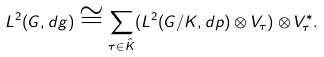Convert formula to latex. <formula><loc_0><loc_0><loc_500><loc_500>L ^ { 2 } ( G , d g ) \cong \sum _ { \tau \in \hat { K } } ( L ^ { 2 } ( G / K , d p ) \otimes V _ { \tau } ) \otimes V _ { \tau } ^ { * } .</formula> 